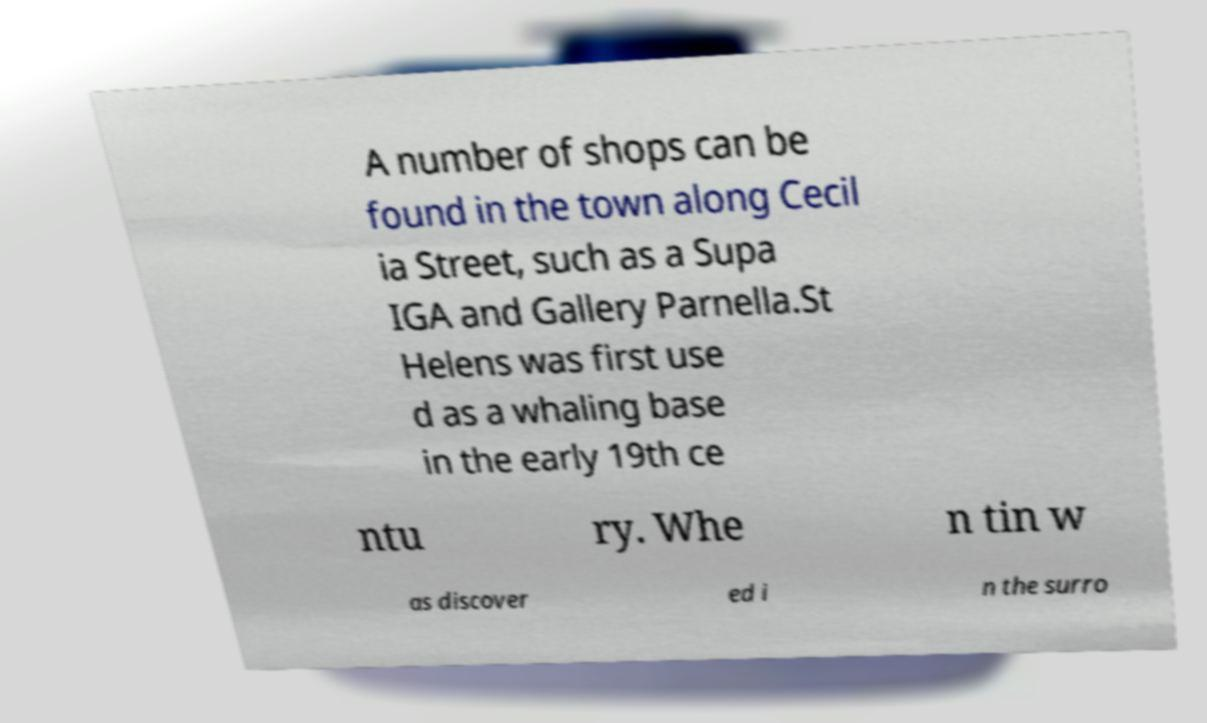Can you accurately transcribe the text from the provided image for me? A number of shops can be found in the town along Cecil ia Street, such as a Supa IGA and Gallery Parnella.St Helens was first use d as a whaling base in the early 19th ce ntu ry. Whe n tin w as discover ed i n the surro 